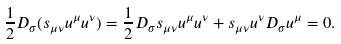Convert formula to latex. <formula><loc_0><loc_0><loc_500><loc_500>\frac { 1 } { 2 } D _ { \sigma } ( s _ { \mu \nu } u ^ { \mu } u ^ { \nu } ) = \frac { 1 } { 2 } D _ { \sigma } s _ { \mu \nu } u ^ { \mu } u ^ { \nu } + s _ { \mu \nu } u ^ { \nu } D _ { \sigma } u ^ { \mu } = 0 .</formula> 